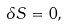Convert formula to latex. <formula><loc_0><loc_0><loc_500><loc_500>\delta S = 0 ,</formula> 